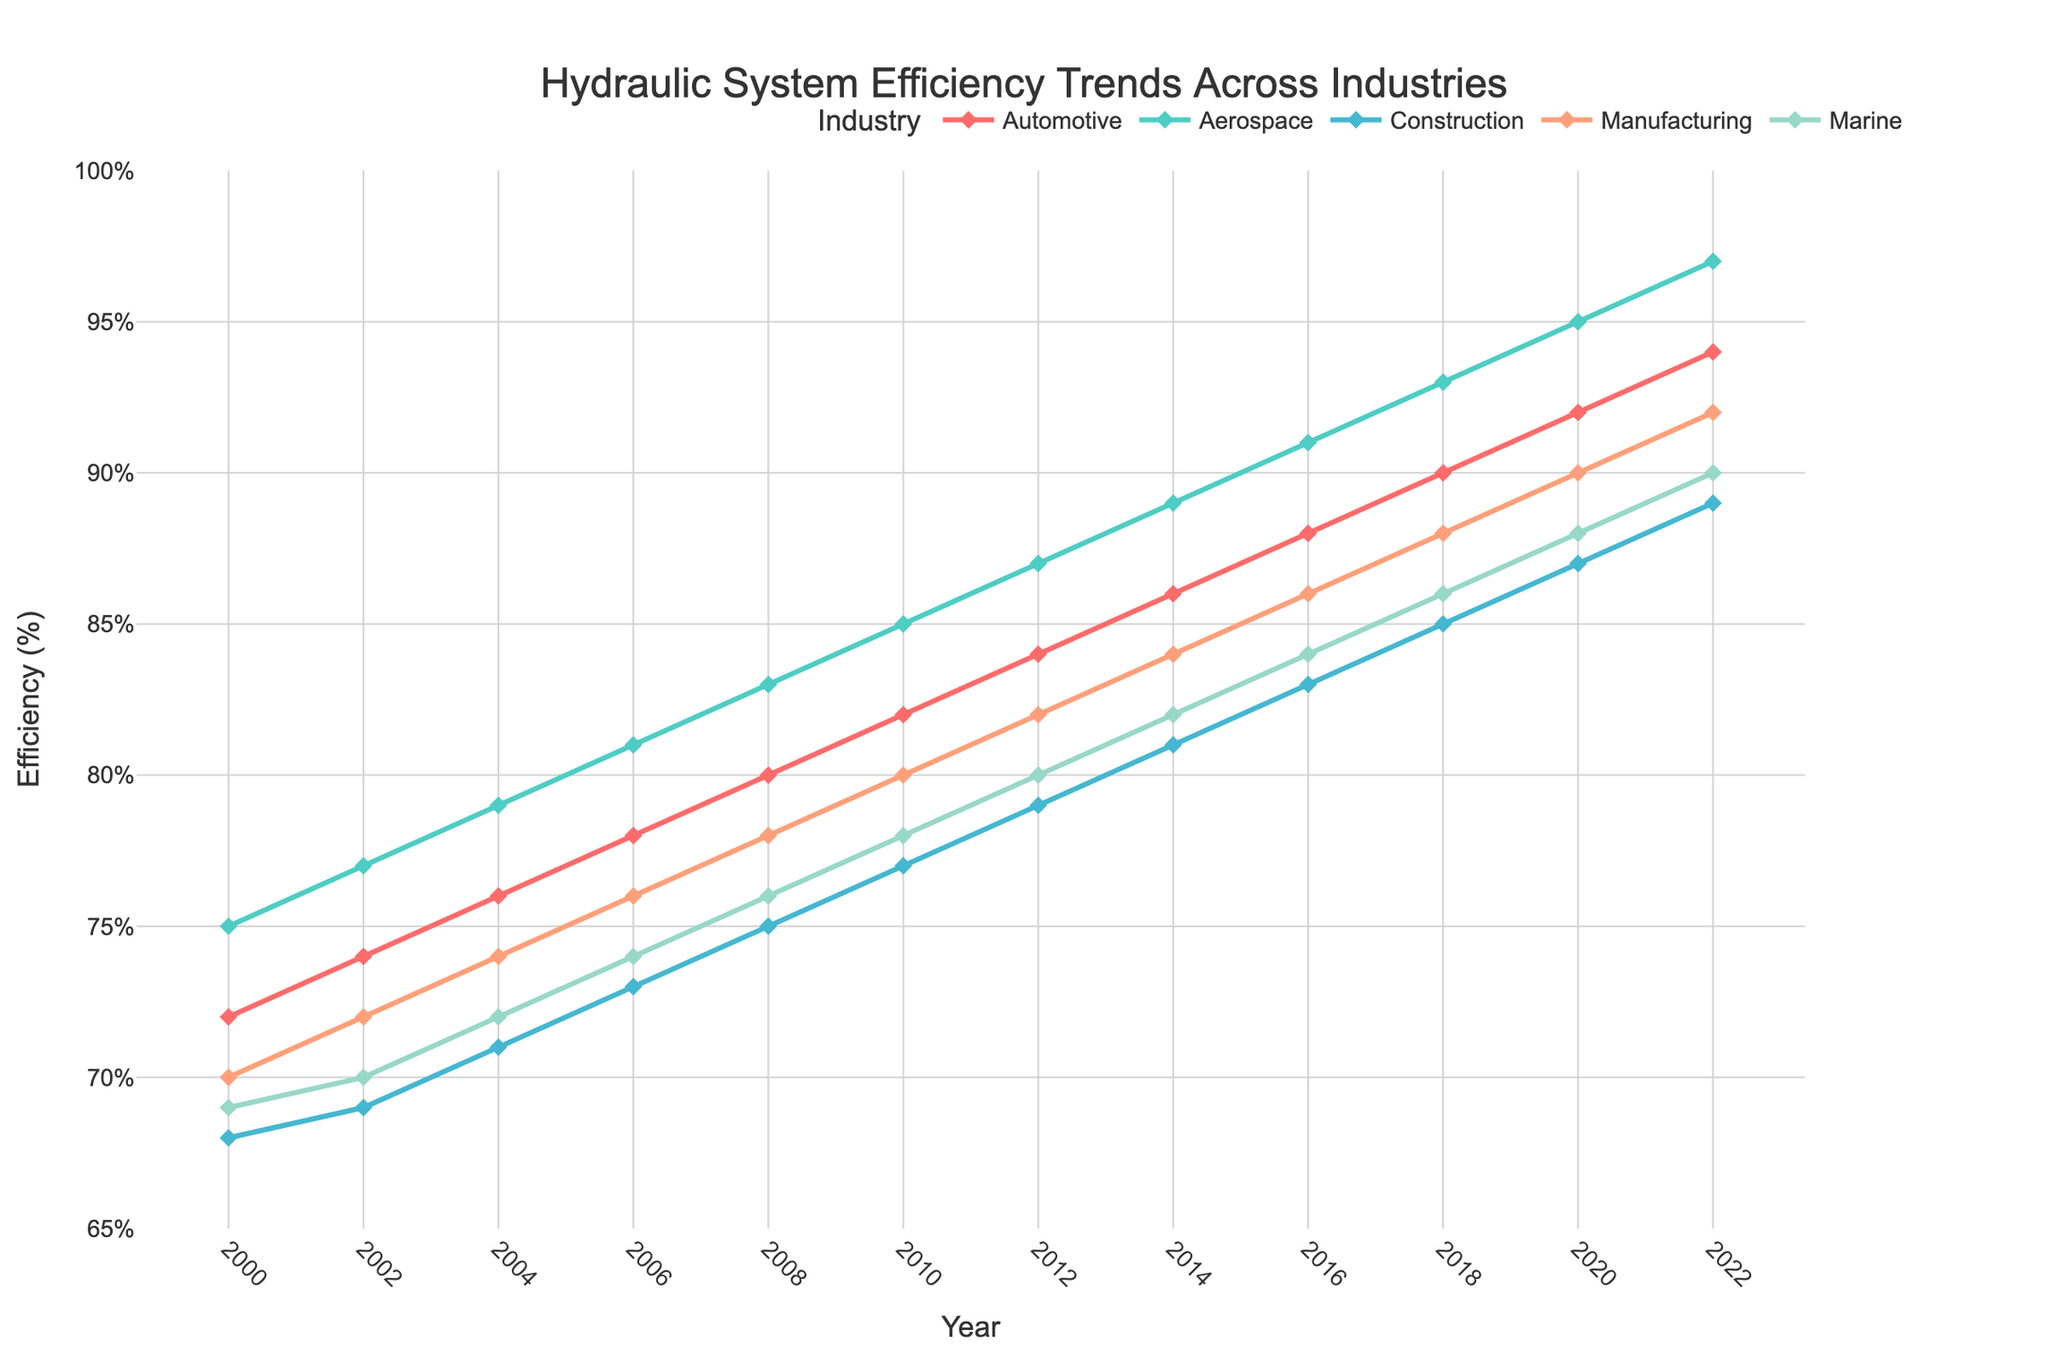What year shows the highest efficiency in the Marine industry? Look at the context of the Marine industry line and identify the highest point on the graph, which corresponds to 2022 with an efficiency of 90%.
Answer: 2022 Which industry had the greatest increase in efficiency from 2000 to 2022? Calculate the difference in efficiency for each industry between 2000 and 2022. Automotive: 94-72=22, Aerospace: 97-75=22, Construction: 89-68=21, Manufacturing: 92-70=22, Marine: 90-69=21. The years correctly show that Automotive, Aerospace, and Manufacturing all have a 22% increase, which is the highest.
Answer: Automotive, Aerospace, Manufacturing In what year did the Construction industry surpass an efficiency of 80%? Observe the graph line for Construction and find the first year when its efficiency crosses 80%, which is 2014.
Answer: 2014 What is the trend in efficiency for the Aerospace industry from 2008 to 2022? Look at the graph for the Aerospace industry from 2008-2022. Notice the efficiency continuously increases from 83% to 97%.
Answer: Increasing By how much did the efficiency of the Manufacturing industry change between 2010 and 2016? Calculate the difference between the efficiency values in 2010 (80%) and 2016 (86%), which is 86-80=6.
Answer: 6 Which industry had a higher efficiency in 2006: Automotive or Marine? Compare the efficiency values for Automotive (78%) and Marine (74%) in 2006. Automotive's efficiency is higher than Marine's.
Answer: Automotive Was there any year when the efficiency of the Construction industry matched the efficiency of the Marine industry? Compare the two lines' values for each year, focusing on Construction and Marine industries. In 2018, both have the efficiency of 86%.
Answer: Yes, 2018 What is the color used to represent the Aerospace industry on the graph? Observe the color of the line and markers used for the Aerospace industry in the legend, represented by green.
Answer: Green What was the average efficiency of the Manufacturing industry between 2000 and 2022? Sum the values of Manufacturing efficiency from 2000 to 2022 and divide by the number of years (70+72+74+76+78+80+82+84+86+88+90+92)/12 = 83.
Answer: 83 Between which years did the Automotive industry see the first increase in efficiency? Look at the points for the Automotive industry and identify when the first increase occurred, between 2000 and 2002.
Answer: 2000 and 2002 